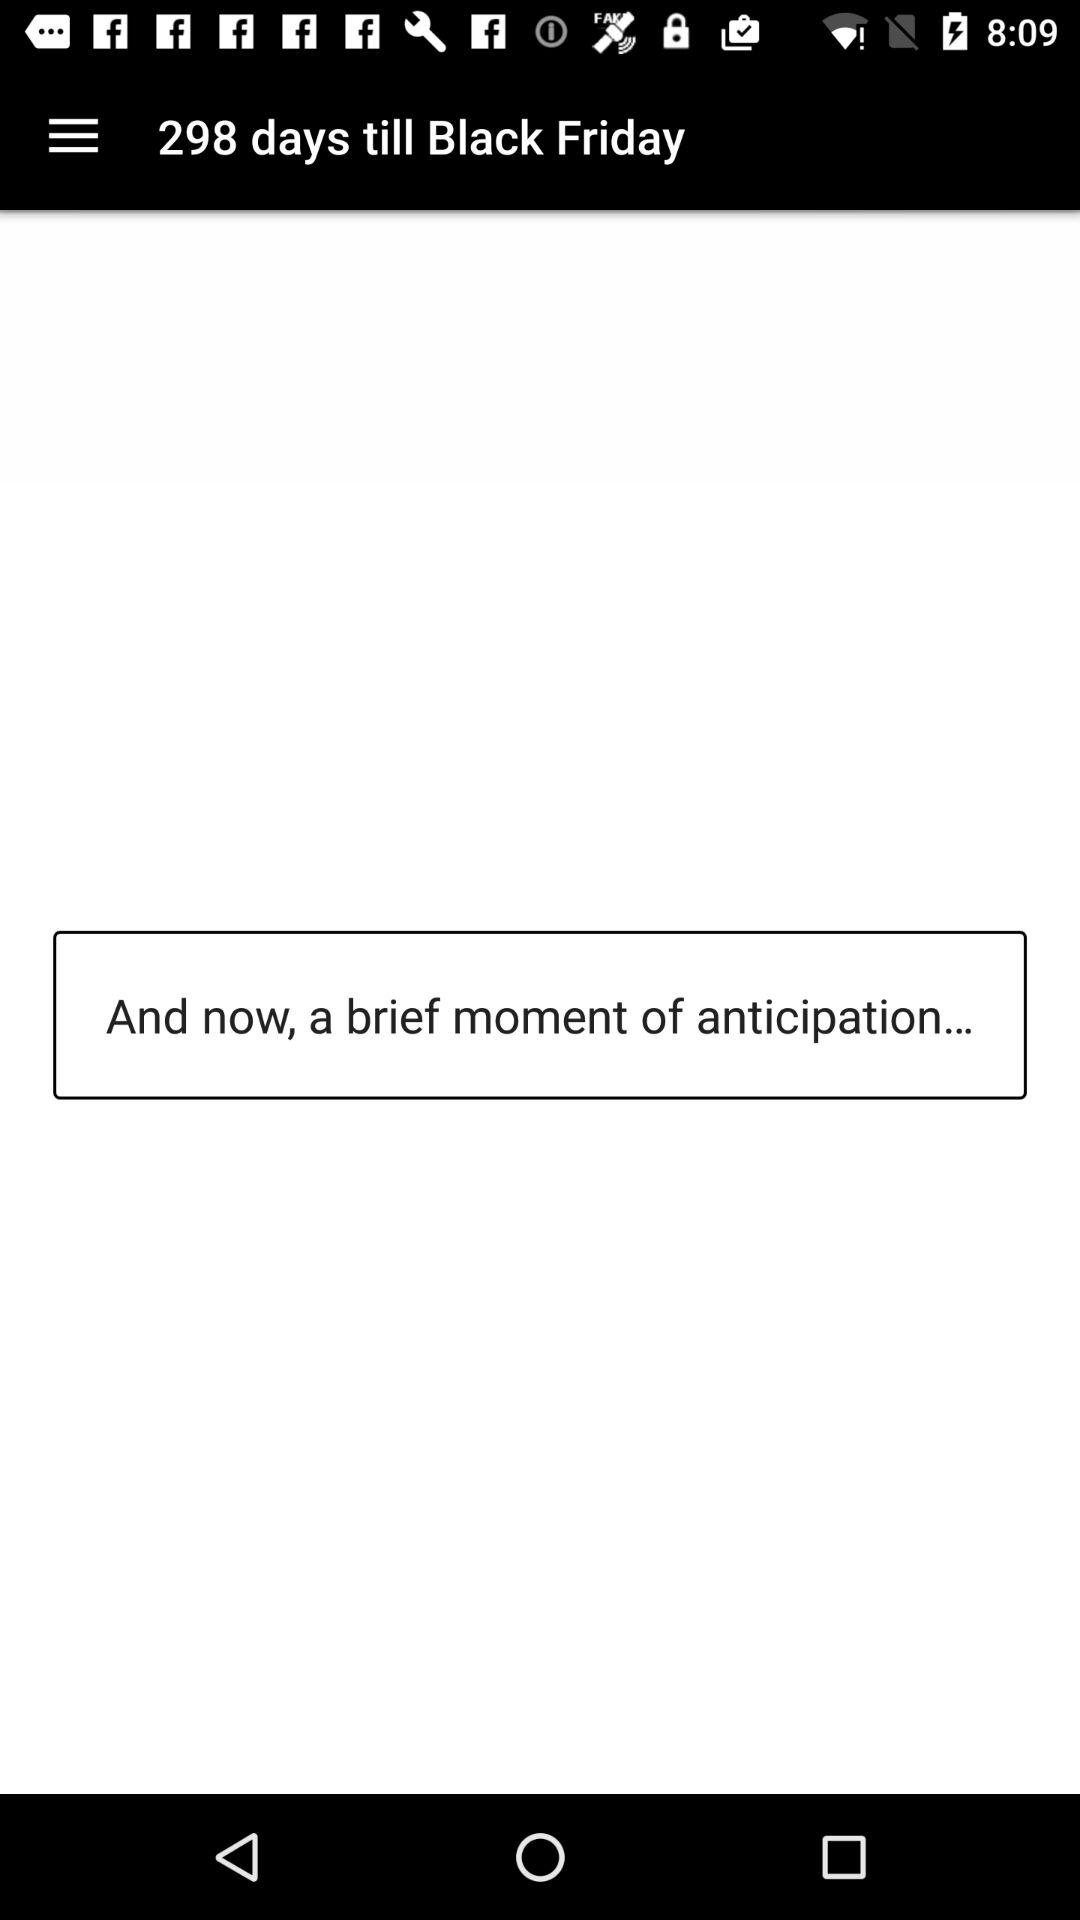How many days are left until Black Friday?
Answer the question using a single word or phrase. 298 